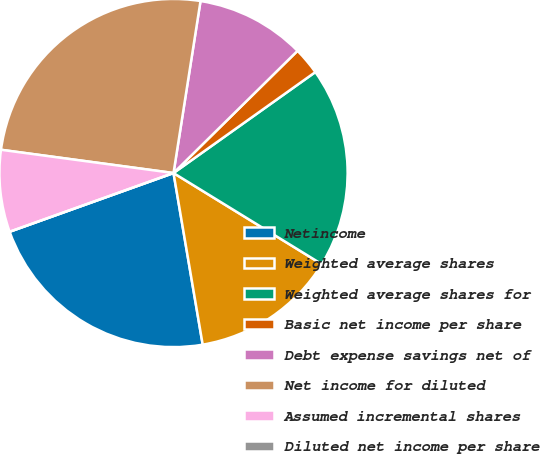<chart> <loc_0><loc_0><loc_500><loc_500><pie_chart><fcel>Netincome<fcel>Weighted average shares<fcel>Weighted average shares for<fcel>Basic net income per share<fcel>Debt expense savings net of<fcel>Net income for diluted<fcel>Assumed incremental shares<fcel>Diluted net income per share<nl><fcel>22.21%<fcel>13.55%<fcel>18.62%<fcel>2.54%<fcel>10.14%<fcel>25.35%<fcel>7.61%<fcel>0.0%<nl></chart> 